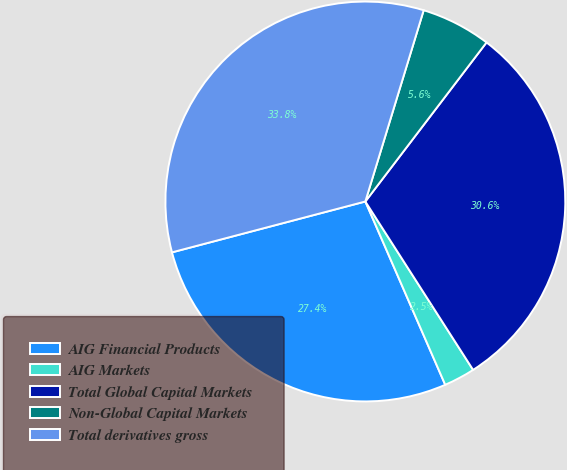Convert chart. <chart><loc_0><loc_0><loc_500><loc_500><pie_chart><fcel>AIG Financial Products<fcel>AIG Markets<fcel>Total Global Capital Markets<fcel>Non-Global Capital Markets<fcel>Total derivatives gross<nl><fcel>27.45%<fcel>2.52%<fcel>30.58%<fcel>5.65%<fcel>33.81%<nl></chart> 